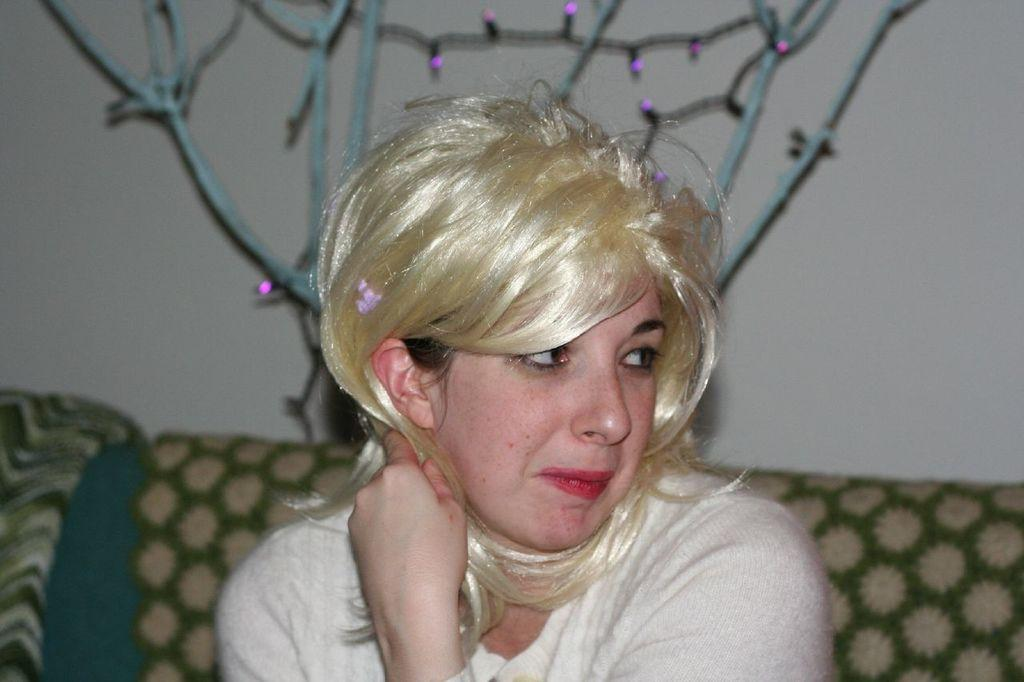Who is the main subject in the image? There is a woman in the image. What is the woman doing in the image? The woman is sitting on a couch. What can be seen behind the woman? There is a wall behind the woman. What type of lighting is present in the image? Serial lights are present in the image. What type of feather can be seen expanding in the building in the image? There is no feather or building present in the image; it features a woman sitting on a couch with a wall behind her and serial lights. 